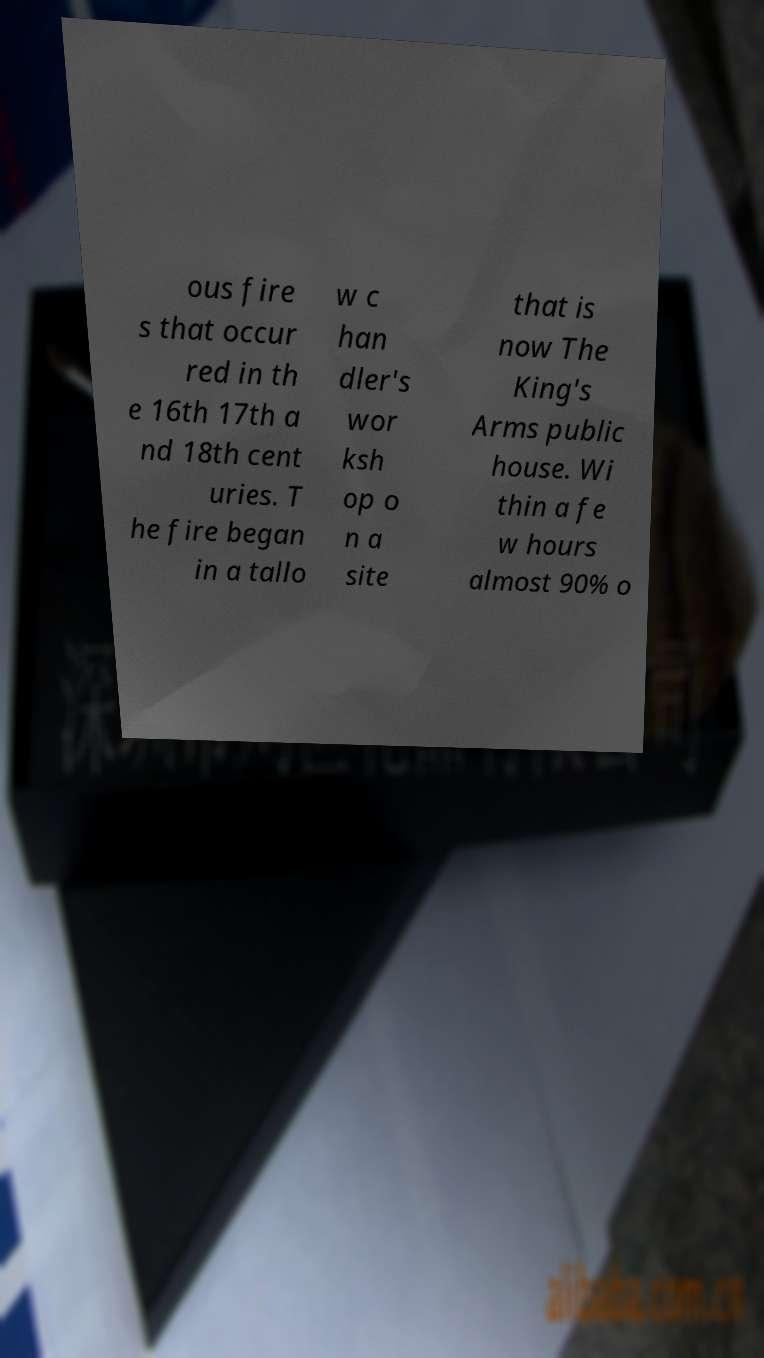Please read and relay the text visible in this image. What does it say? ous fire s that occur red in th e 16th 17th a nd 18th cent uries. T he fire began in a tallo w c han dler's wor ksh op o n a site that is now The King's Arms public house. Wi thin a fe w hours almost 90% o 